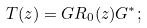Convert formula to latex. <formula><loc_0><loc_0><loc_500><loc_500>T ( z ) = G R _ { 0 } ( z ) G ^ { * } ;</formula> 